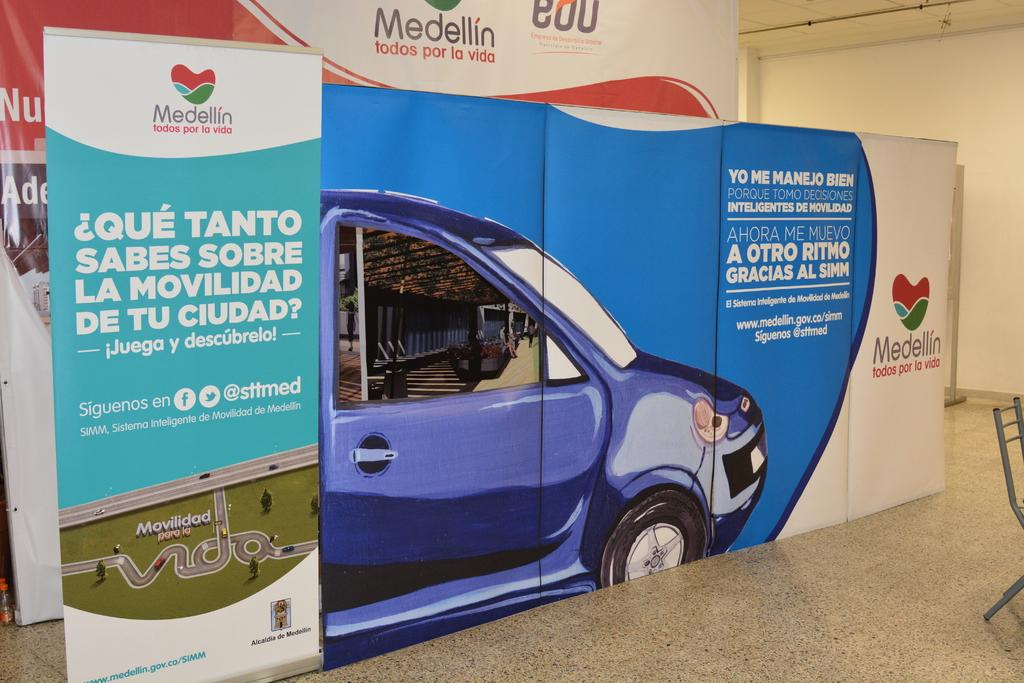What type of signage is present in the image? There are hoardings in the image. What type of furniture is present in the image? There is a chair in the image. What type of structure is present in the image? There is a wall in the image. What type of religious exchange is taking place in the image? There is no religious exchange present in the image; it only features hoardings, a chair, and a wall. What type of friction can be seen between the chair and the wall in the image? There is no friction between the chair and the wall in the image; they are simply separate objects in the same space. 